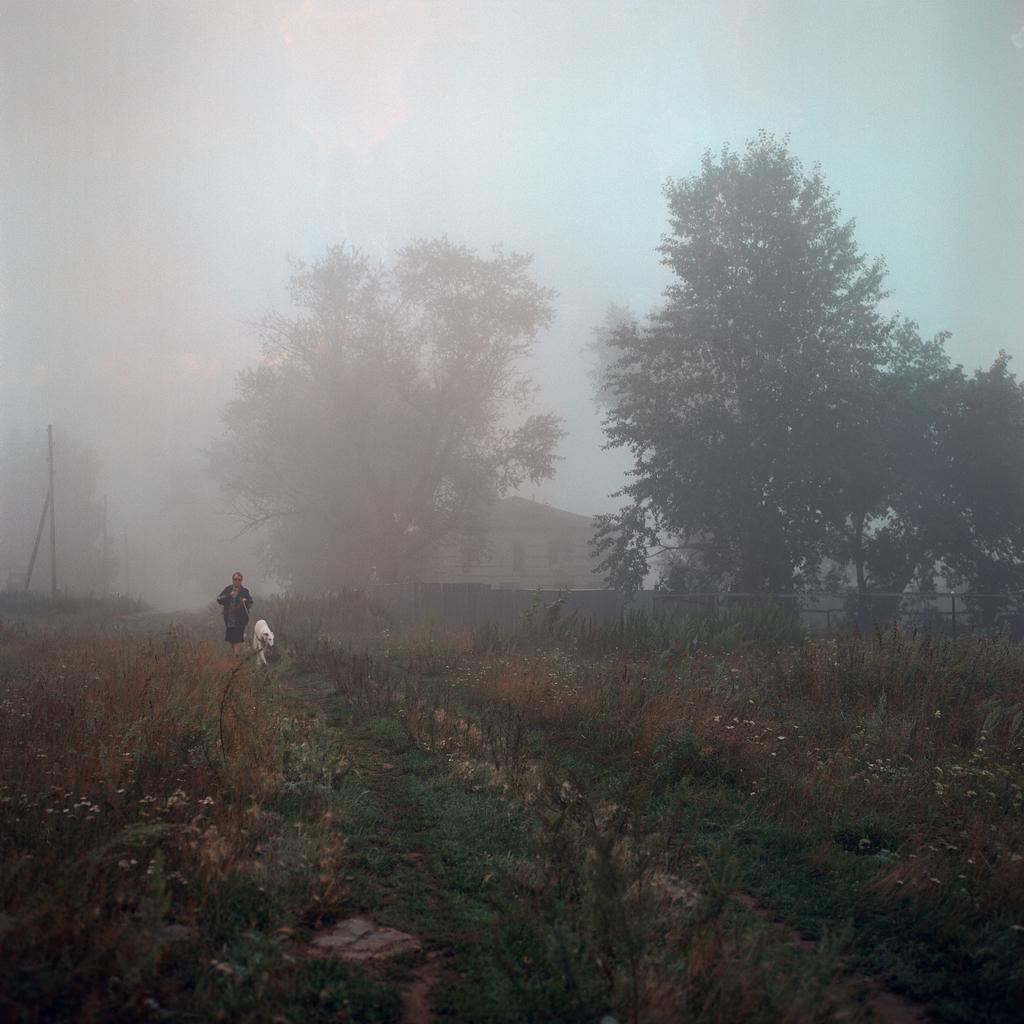Who is present in the image? There is a lady in the image. What other living creature is present in the image? There is a dog in the image. Where are the lady and the dog located in the image? The lady and the dog are on the left side of the image. What can be seen in the background of the image? There is greenery around the area of the image. What structure is located in the center of the image? There is a house in the center of the image. Where is the cave located in the image? There is no cave present in the image. What color is the cap worn by the lady in the image? There is no cap worn by the lady in the image. 